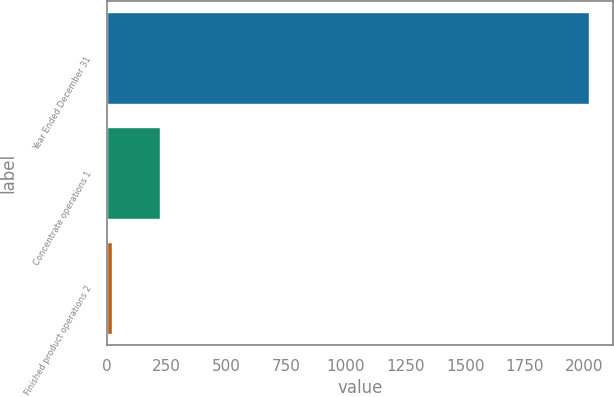Convert chart to OTSL. <chart><loc_0><loc_0><loc_500><loc_500><bar_chart><fcel>Year Ended December 31<fcel>Concentrate operations 1<fcel>Finished product operations 2<nl><fcel>2017<fcel>221.5<fcel>22<nl></chart> 